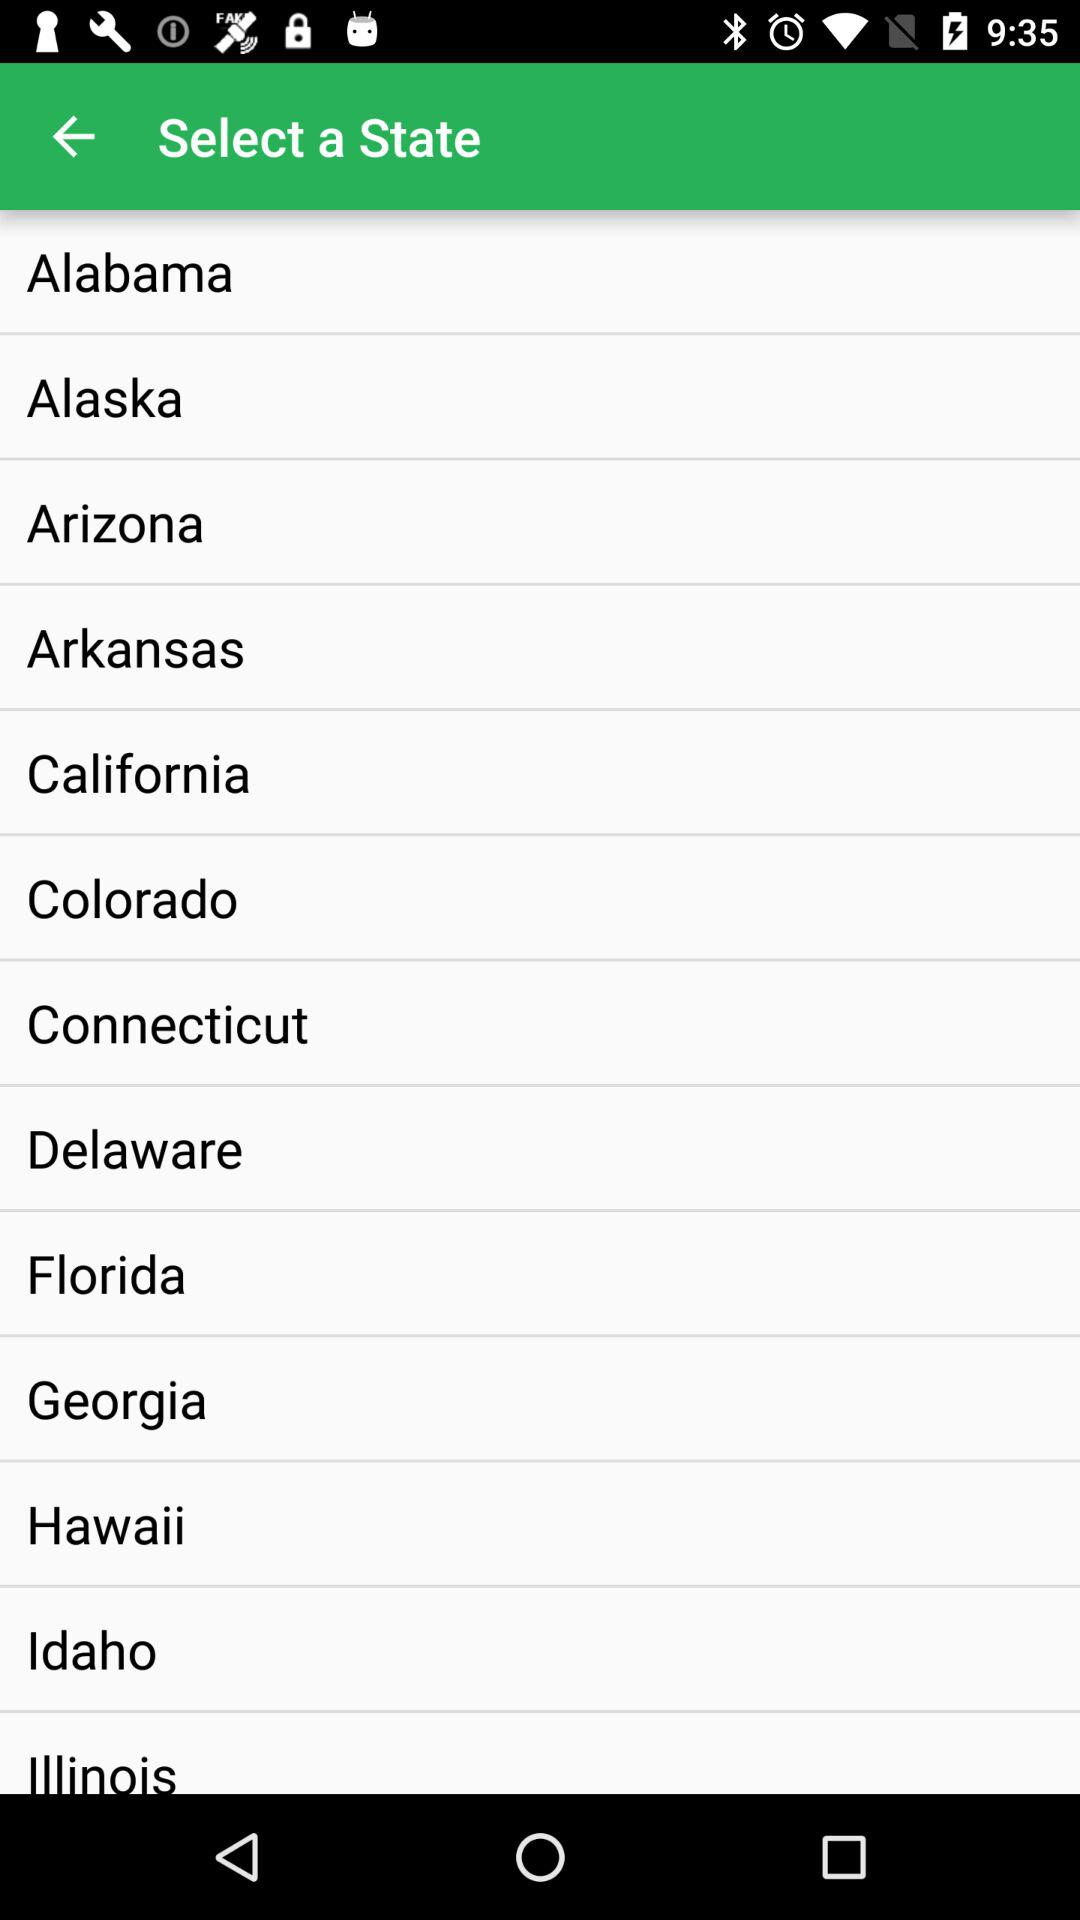What are the options to select the state from which I can select? The options to select the state are "Alabama", "Alaska", "Arizona", "Arkansas", "California", "Colorado", "Connecticut", "Delaware", "Florida", "Georgia", "Hawaii" and "Idaho". 